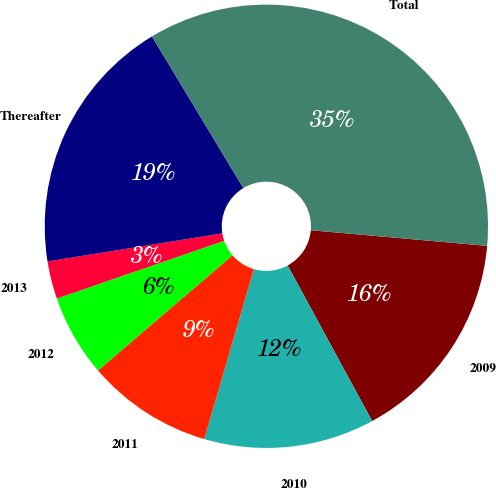Convert chart. <chart><loc_0><loc_0><loc_500><loc_500><pie_chart><fcel>2009<fcel>2010<fcel>2011<fcel>2012<fcel>2013<fcel>Thereafter<fcel>Total<nl><fcel>15.67%<fcel>12.44%<fcel>9.21%<fcel>5.98%<fcel>2.75%<fcel>18.9%<fcel>35.04%<nl></chart> 